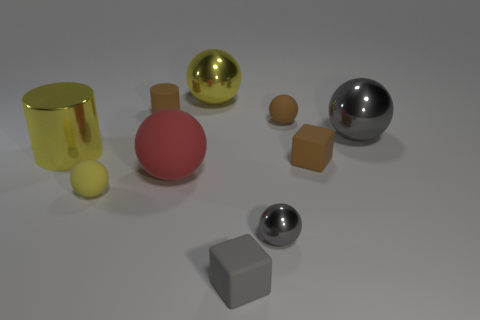There is another big metallic thing that is the same shape as the big gray shiny thing; what is its color?
Your answer should be compact. Yellow. Are there more big yellow metal blocks than shiny things?
Give a very brief answer. No. Do the gray cube and the big yellow ball have the same material?
Offer a terse response. No. What number of other large red things are made of the same material as the red thing?
Your answer should be compact. 0. There is a red sphere; is its size the same as the yellow ball in front of the tiny cylinder?
Make the answer very short. No. What is the color of the small thing that is both behind the yellow rubber ball and on the left side of the large yellow metal sphere?
Your answer should be very brief. Brown. There is a small gray object left of the tiny metallic sphere; is there a big yellow thing on the right side of it?
Keep it short and to the point. No. Are there the same number of metal spheres on the left side of the small yellow matte object and small gray rubber blocks?
Your answer should be very brief. No. There is a gray ball in front of the matte block that is behind the tiny gray matte cube; what number of matte balls are to the right of it?
Offer a very short reply. 1. Is there a gray rubber block that has the same size as the matte cylinder?
Make the answer very short. Yes. 